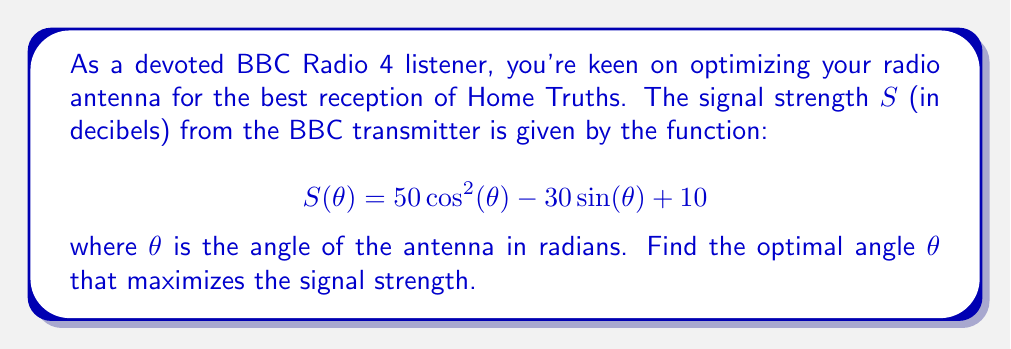What is the answer to this math problem? To find the optimal angle, we need to maximize the function $S(\theta)$. This can be done by finding the derivative of $S(\theta)$, setting it to zero, and solving for $\theta$.

Step 1: Calculate the derivative of $S(\theta)$
$$\frac{dS}{d\theta} = -100\cos(\theta)\sin(\theta) - 30\cos(\theta)$$

Step 2: Set the derivative to zero and solve
$$-100\cos(\theta)\sin(\theta) - 30\cos(\theta) = 0$$
$$\cos(\theta)(-100\sin(\theta) - 30) = 0$$

This equation is satisfied when either $\cos(\theta) = 0$ or $-100\sin(\theta) - 30 = 0$

Case 1: $\cos(\theta) = 0$
This occurs when $\theta = \frac{\pi}{2}$ or $\frac{3\pi}{2}$, but these are not maxima.

Case 2: $-100\sin(\theta) - 30 = 0$
$$\sin(\theta) = -0.3$$
$$\theta = \arcsin(-0.3) \approx -0.3047 \text{ radians}$$

Step 3: Verify this is a maximum by checking the second derivative
$$\frac{d^2S}{d\theta^2} = -100(\cos^2(\theta) - \sin^2(\theta)) + 30\sin(\theta)$$
At $\theta \approx -0.3047$, this is negative, confirming a maximum.

Step 4: Convert to degrees
$$\theta \approx -0.3047 \text{ radians} \times \frac{180°}{\pi} \approx -17.46°$$
Answer: $-17.46°$ 